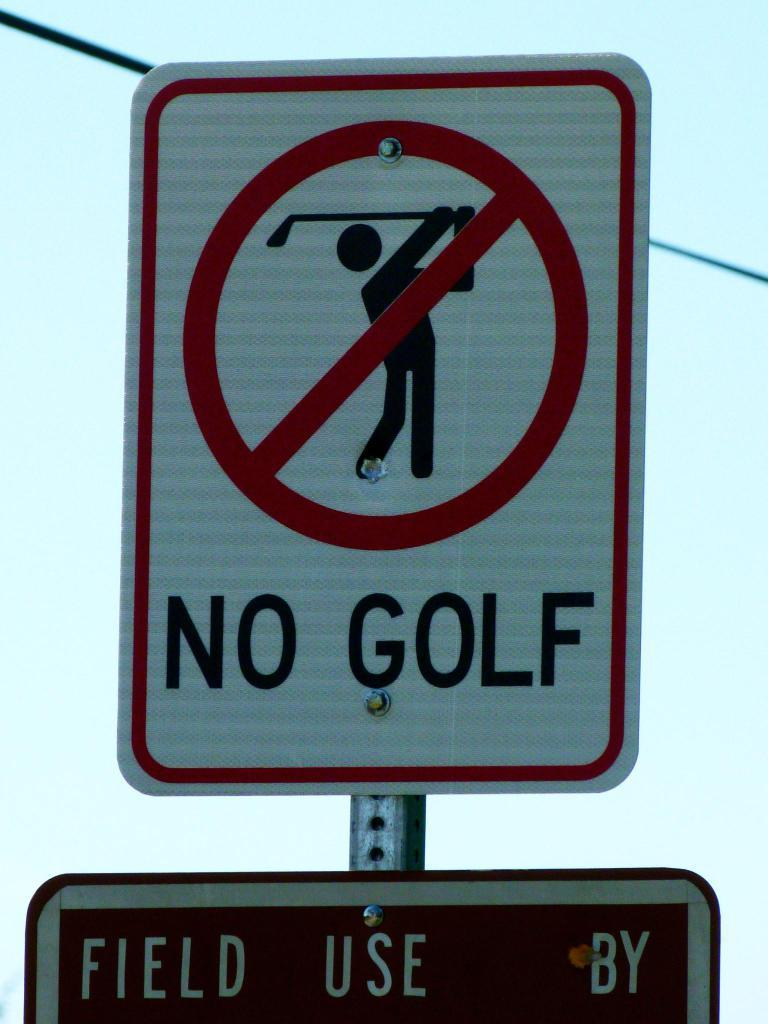<image>
Share a concise interpretation of the image provided. the words no golf is on some kind of sign 